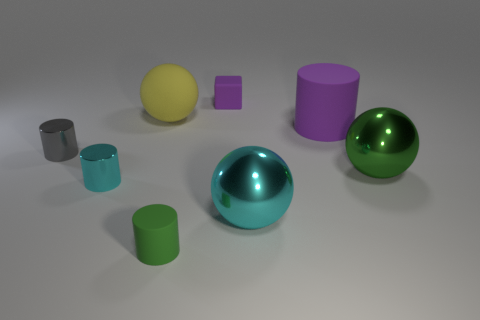The large thing left of the small block has what shape?
Make the answer very short. Sphere. There is a yellow thing that is the same size as the green sphere; what shape is it?
Keep it short and to the point. Sphere. Is there a big green shiny thing that has the same shape as the large yellow thing?
Offer a very short reply. Yes. There is a rubber object that is in front of the tiny cyan shiny cylinder; is its shape the same as the tiny object that is behind the big yellow ball?
Your answer should be compact. No. What material is the purple object that is the same size as the gray shiny cylinder?
Make the answer very short. Rubber. The purple matte object right of the small purple cube on the left side of the large cyan metallic thing is what shape?
Your answer should be compact. Cylinder. How many objects are either green cylinders or purple objects that are behind the large yellow sphere?
Your answer should be compact. 2. How many other things are the same color as the matte ball?
Offer a terse response. 0. What number of yellow things are either rubber objects or tiny rubber blocks?
Your response must be concise. 1. Is there a cylinder that is in front of the green thing behind the cyan shiny object that is on the left side of the small green object?
Your answer should be very brief. Yes. 